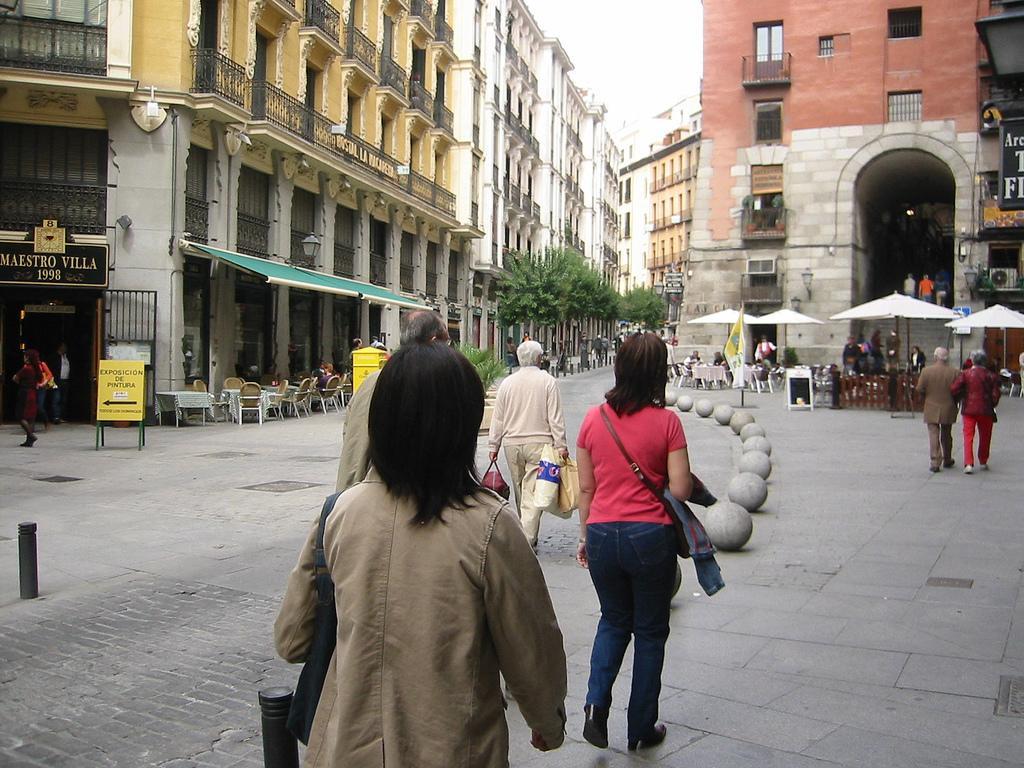In one or two sentences, can you explain what this image depicts? A woman is walking on the footpath, she wore a coat. On the right side there are umbrellas and also buildings 